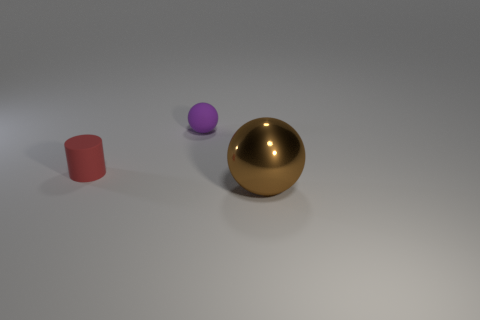What is the shape of the matte object left of the small purple ball on the right side of the small rubber cylinder?
Your response must be concise. Cylinder. Are there fewer small purple spheres that are left of the small purple rubber thing than big cyan matte balls?
Make the answer very short. No. The large brown object is what shape?
Your answer should be very brief. Sphere. There is a thing that is on the right side of the matte ball; how big is it?
Your answer should be compact. Large. There is a sphere that is the same size as the red object; what color is it?
Ensure brevity in your answer.  Purple. Are there any rubber balls that have the same color as the big thing?
Your response must be concise. No. Are there fewer big brown shiny things that are in front of the matte cylinder than small red things that are on the right side of the purple ball?
Your answer should be very brief. No. There is a thing that is in front of the small sphere and to the right of the tiny red thing; what material is it made of?
Offer a very short reply. Metal. There is a large object; is it the same shape as the small object on the right side of the red thing?
Provide a short and direct response. Yes. What number of other objects are the same size as the brown metallic sphere?
Offer a terse response. 0. 